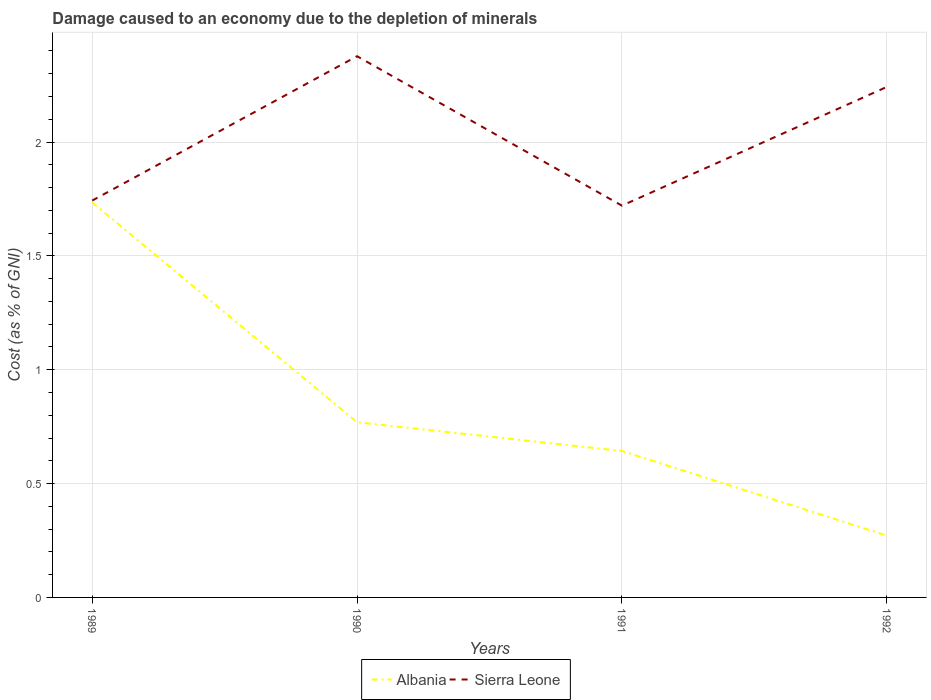How many different coloured lines are there?
Provide a succinct answer. 2. Does the line corresponding to Albania intersect with the line corresponding to Sierra Leone?
Keep it short and to the point. No. Is the number of lines equal to the number of legend labels?
Offer a very short reply. Yes. Across all years, what is the maximum cost of damage caused due to the depletion of minerals in Sierra Leone?
Offer a very short reply. 1.72. What is the total cost of damage caused due to the depletion of minerals in Albania in the graph?
Keep it short and to the point. 1.46. What is the difference between the highest and the second highest cost of damage caused due to the depletion of minerals in Sierra Leone?
Provide a succinct answer. 0.66. How many lines are there?
Offer a terse response. 2. How many years are there in the graph?
Provide a succinct answer. 4. Does the graph contain grids?
Ensure brevity in your answer.  Yes. Where does the legend appear in the graph?
Your response must be concise. Bottom center. What is the title of the graph?
Provide a short and direct response. Damage caused to an economy due to the depletion of minerals. What is the label or title of the X-axis?
Your answer should be very brief. Years. What is the label or title of the Y-axis?
Give a very brief answer. Cost (as % of GNI). What is the Cost (as % of GNI) in Albania in 1989?
Give a very brief answer. 1.73. What is the Cost (as % of GNI) of Sierra Leone in 1989?
Give a very brief answer. 1.74. What is the Cost (as % of GNI) in Albania in 1990?
Offer a terse response. 0.77. What is the Cost (as % of GNI) in Sierra Leone in 1990?
Offer a terse response. 2.38. What is the Cost (as % of GNI) in Albania in 1991?
Your answer should be very brief. 0.64. What is the Cost (as % of GNI) of Sierra Leone in 1991?
Make the answer very short. 1.72. What is the Cost (as % of GNI) of Albania in 1992?
Give a very brief answer. 0.27. What is the Cost (as % of GNI) in Sierra Leone in 1992?
Offer a very short reply. 2.24. Across all years, what is the maximum Cost (as % of GNI) of Albania?
Make the answer very short. 1.73. Across all years, what is the maximum Cost (as % of GNI) in Sierra Leone?
Make the answer very short. 2.38. Across all years, what is the minimum Cost (as % of GNI) of Albania?
Your response must be concise. 0.27. Across all years, what is the minimum Cost (as % of GNI) of Sierra Leone?
Provide a short and direct response. 1.72. What is the total Cost (as % of GNI) of Albania in the graph?
Ensure brevity in your answer.  3.42. What is the total Cost (as % of GNI) in Sierra Leone in the graph?
Your answer should be very brief. 8.08. What is the difference between the Cost (as % of GNI) of Albania in 1989 and that in 1990?
Offer a terse response. 0.97. What is the difference between the Cost (as % of GNI) in Sierra Leone in 1989 and that in 1990?
Give a very brief answer. -0.63. What is the difference between the Cost (as % of GNI) in Albania in 1989 and that in 1991?
Provide a succinct answer. 1.09. What is the difference between the Cost (as % of GNI) in Sierra Leone in 1989 and that in 1991?
Offer a very short reply. 0.02. What is the difference between the Cost (as % of GNI) of Albania in 1989 and that in 1992?
Provide a short and direct response. 1.46. What is the difference between the Cost (as % of GNI) of Sierra Leone in 1989 and that in 1992?
Provide a succinct answer. -0.5. What is the difference between the Cost (as % of GNI) of Albania in 1990 and that in 1991?
Make the answer very short. 0.13. What is the difference between the Cost (as % of GNI) of Sierra Leone in 1990 and that in 1991?
Keep it short and to the point. 0.66. What is the difference between the Cost (as % of GNI) in Albania in 1990 and that in 1992?
Provide a succinct answer. 0.5. What is the difference between the Cost (as % of GNI) in Sierra Leone in 1990 and that in 1992?
Provide a short and direct response. 0.13. What is the difference between the Cost (as % of GNI) of Albania in 1991 and that in 1992?
Ensure brevity in your answer.  0.37. What is the difference between the Cost (as % of GNI) of Sierra Leone in 1991 and that in 1992?
Give a very brief answer. -0.52. What is the difference between the Cost (as % of GNI) of Albania in 1989 and the Cost (as % of GNI) of Sierra Leone in 1990?
Provide a succinct answer. -0.64. What is the difference between the Cost (as % of GNI) in Albania in 1989 and the Cost (as % of GNI) in Sierra Leone in 1991?
Make the answer very short. 0.01. What is the difference between the Cost (as % of GNI) in Albania in 1989 and the Cost (as % of GNI) in Sierra Leone in 1992?
Keep it short and to the point. -0.51. What is the difference between the Cost (as % of GNI) of Albania in 1990 and the Cost (as % of GNI) of Sierra Leone in 1991?
Keep it short and to the point. -0.95. What is the difference between the Cost (as % of GNI) of Albania in 1990 and the Cost (as % of GNI) of Sierra Leone in 1992?
Ensure brevity in your answer.  -1.47. What is the difference between the Cost (as % of GNI) of Albania in 1991 and the Cost (as % of GNI) of Sierra Leone in 1992?
Offer a terse response. -1.6. What is the average Cost (as % of GNI) of Albania per year?
Make the answer very short. 0.85. What is the average Cost (as % of GNI) of Sierra Leone per year?
Keep it short and to the point. 2.02. In the year 1989, what is the difference between the Cost (as % of GNI) of Albania and Cost (as % of GNI) of Sierra Leone?
Your response must be concise. -0.01. In the year 1990, what is the difference between the Cost (as % of GNI) of Albania and Cost (as % of GNI) of Sierra Leone?
Your response must be concise. -1.61. In the year 1991, what is the difference between the Cost (as % of GNI) in Albania and Cost (as % of GNI) in Sierra Leone?
Provide a short and direct response. -1.08. In the year 1992, what is the difference between the Cost (as % of GNI) of Albania and Cost (as % of GNI) of Sierra Leone?
Provide a short and direct response. -1.97. What is the ratio of the Cost (as % of GNI) of Albania in 1989 to that in 1990?
Your response must be concise. 2.25. What is the ratio of the Cost (as % of GNI) in Sierra Leone in 1989 to that in 1990?
Provide a short and direct response. 0.73. What is the ratio of the Cost (as % of GNI) of Albania in 1989 to that in 1991?
Make the answer very short. 2.7. What is the ratio of the Cost (as % of GNI) of Sierra Leone in 1989 to that in 1991?
Provide a succinct answer. 1.01. What is the ratio of the Cost (as % of GNI) in Albania in 1989 to that in 1992?
Keep it short and to the point. 6.39. What is the ratio of the Cost (as % of GNI) of Sierra Leone in 1989 to that in 1992?
Your answer should be compact. 0.78. What is the ratio of the Cost (as % of GNI) of Albania in 1990 to that in 1991?
Ensure brevity in your answer.  1.2. What is the ratio of the Cost (as % of GNI) of Sierra Leone in 1990 to that in 1991?
Your response must be concise. 1.38. What is the ratio of the Cost (as % of GNI) in Albania in 1990 to that in 1992?
Ensure brevity in your answer.  2.83. What is the ratio of the Cost (as % of GNI) in Sierra Leone in 1990 to that in 1992?
Make the answer very short. 1.06. What is the ratio of the Cost (as % of GNI) of Albania in 1991 to that in 1992?
Keep it short and to the point. 2.37. What is the ratio of the Cost (as % of GNI) in Sierra Leone in 1991 to that in 1992?
Your answer should be very brief. 0.77. What is the difference between the highest and the second highest Cost (as % of GNI) in Albania?
Make the answer very short. 0.97. What is the difference between the highest and the second highest Cost (as % of GNI) in Sierra Leone?
Provide a short and direct response. 0.13. What is the difference between the highest and the lowest Cost (as % of GNI) in Albania?
Provide a short and direct response. 1.46. What is the difference between the highest and the lowest Cost (as % of GNI) of Sierra Leone?
Give a very brief answer. 0.66. 